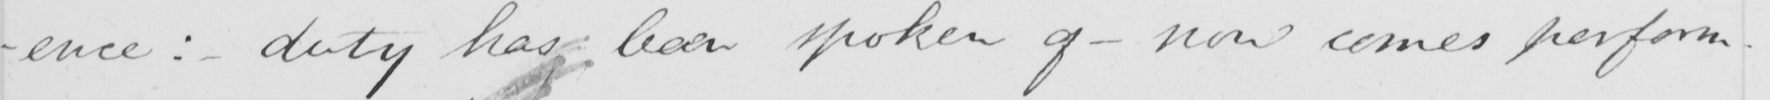Can you tell me what this handwritten text says? -ence :  - duty has been spoken of  _  now comes perform- 